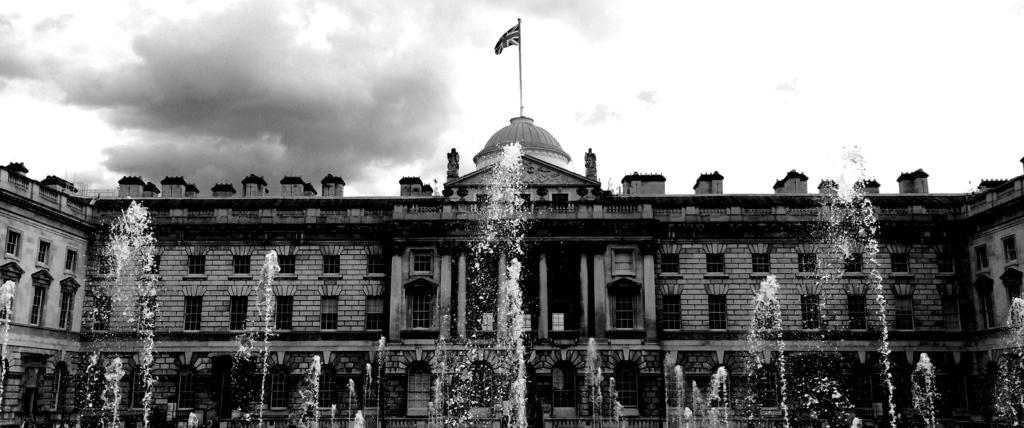What is the color scheme of the image? The image is black and white. What natural element can be seen in the image? There is water visible in the image. What is located in the background of the image? There is a building in the background of the image. What architectural features are present on the building? There are windows and a flag on the building. What is visible in the sky in the image? Clouds are present in the sky. Where is the gun located in the image? There is no gun present in the image. What type of market can be seen in the image? There is no market visible in the image. 